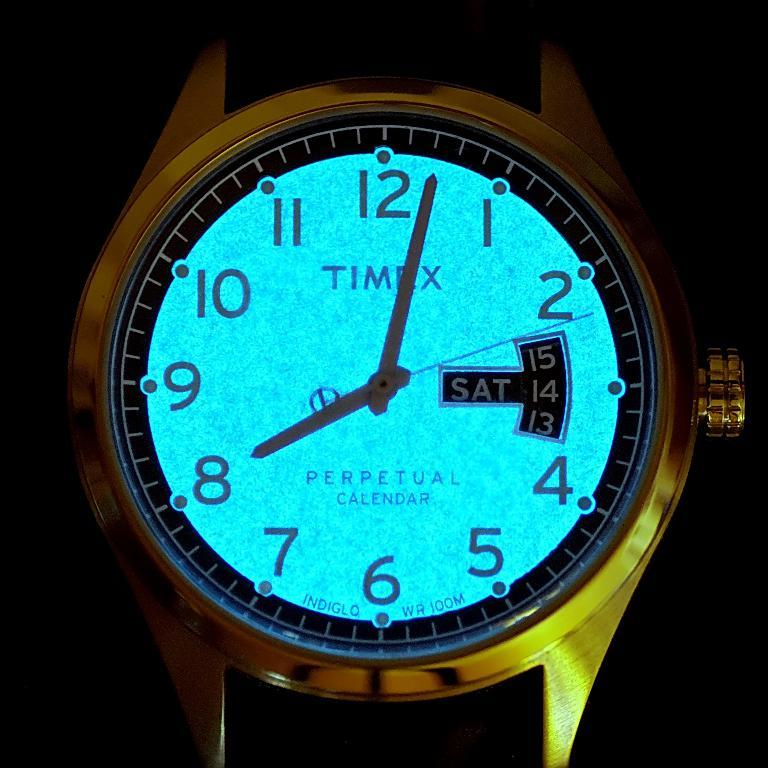<image>
Share a concise interpretation of the image provided. A Timex watch with a light-up face has a perpetual calendar. 